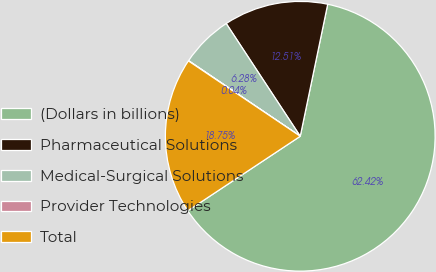<chart> <loc_0><loc_0><loc_500><loc_500><pie_chart><fcel>(Dollars in billions)<fcel>Pharmaceutical Solutions<fcel>Medical-Surgical Solutions<fcel>Provider Technologies<fcel>Total<nl><fcel>62.42%<fcel>12.51%<fcel>6.28%<fcel>0.04%<fcel>18.75%<nl></chart> 